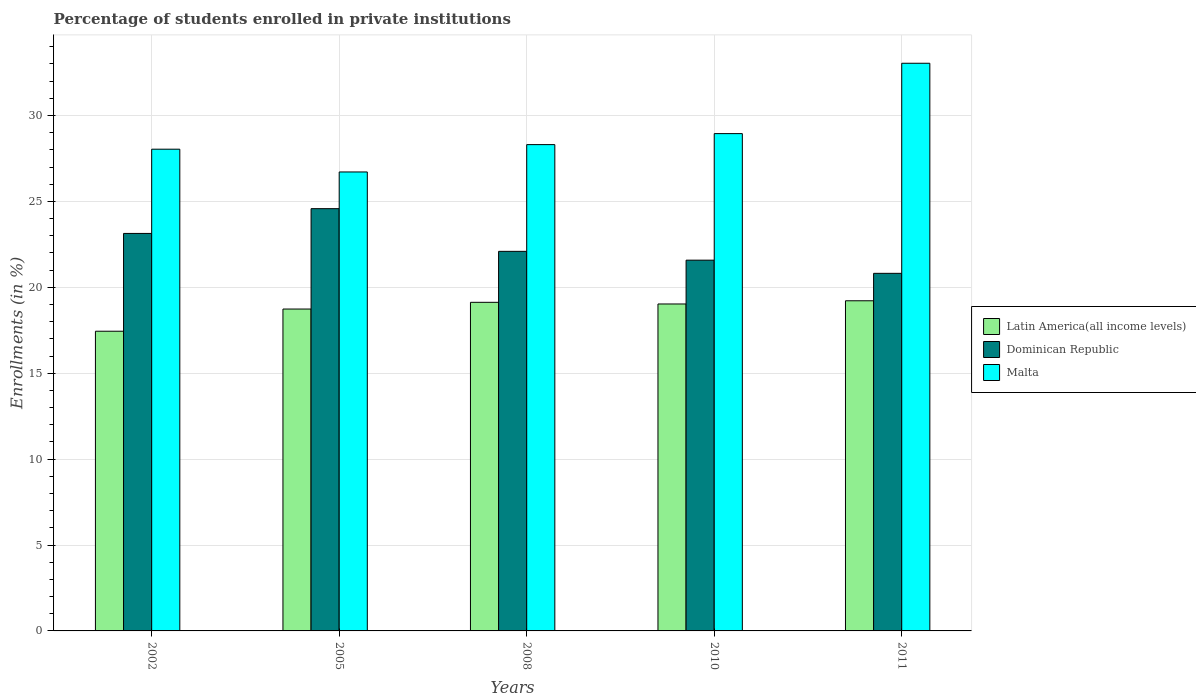How many groups of bars are there?
Provide a short and direct response. 5. Are the number of bars per tick equal to the number of legend labels?
Offer a very short reply. Yes. How many bars are there on the 4th tick from the left?
Provide a succinct answer. 3. What is the percentage of trained teachers in Dominican Republic in 2005?
Provide a succinct answer. 24.58. Across all years, what is the maximum percentage of trained teachers in Latin America(all income levels)?
Ensure brevity in your answer.  19.22. Across all years, what is the minimum percentage of trained teachers in Malta?
Provide a succinct answer. 26.71. In which year was the percentage of trained teachers in Malta maximum?
Provide a short and direct response. 2011. In which year was the percentage of trained teachers in Dominican Republic minimum?
Keep it short and to the point. 2011. What is the total percentage of trained teachers in Dominican Republic in the graph?
Give a very brief answer. 112.2. What is the difference between the percentage of trained teachers in Latin America(all income levels) in 2005 and that in 2008?
Ensure brevity in your answer.  -0.39. What is the difference between the percentage of trained teachers in Malta in 2008 and the percentage of trained teachers in Dominican Republic in 2010?
Provide a succinct answer. 6.72. What is the average percentage of trained teachers in Dominican Republic per year?
Make the answer very short. 22.44. In the year 2002, what is the difference between the percentage of trained teachers in Malta and percentage of trained teachers in Latin America(all income levels)?
Keep it short and to the point. 10.59. What is the ratio of the percentage of trained teachers in Malta in 2002 to that in 2011?
Ensure brevity in your answer.  0.85. Is the percentage of trained teachers in Latin America(all income levels) in 2005 less than that in 2011?
Your response must be concise. Yes. Is the difference between the percentage of trained teachers in Malta in 2002 and 2011 greater than the difference between the percentage of trained teachers in Latin America(all income levels) in 2002 and 2011?
Make the answer very short. No. What is the difference between the highest and the second highest percentage of trained teachers in Latin America(all income levels)?
Your answer should be very brief. 0.09. What is the difference between the highest and the lowest percentage of trained teachers in Latin America(all income levels)?
Offer a terse response. 1.77. In how many years, is the percentage of trained teachers in Latin America(all income levels) greater than the average percentage of trained teachers in Latin America(all income levels) taken over all years?
Ensure brevity in your answer.  4. What does the 2nd bar from the left in 2011 represents?
Make the answer very short. Dominican Republic. What does the 3rd bar from the right in 2010 represents?
Your answer should be compact. Latin America(all income levels). Is it the case that in every year, the sum of the percentage of trained teachers in Malta and percentage of trained teachers in Latin America(all income levels) is greater than the percentage of trained teachers in Dominican Republic?
Your response must be concise. Yes. Does the graph contain grids?
Your response must be concise. Yes. Where does the legend appear in the graph?
Give a very brief answer. Center right. How many legend labels are there?
Give a very brief answer. 3. What is the title of the graph?
Keep it short and to the point. Percentage of students enrolled in private institutions. Does "Mauritania" appear as one of the legend labels in the graph?
Ensure brevity in your answer.  No. What is the label or title of the Y-axis?
Provide a short and direct response. Enrollments (in %). What is the Enrollments (in %) in Latin America(all income levels) in 2002?
Your answer should be compact. 17.44. What is the Enrollments (in %) of Dominican Republic in 2002?
Provide a short and direct response. 23.14. What is the Enrollments (in %) of Malta in 2002?
Keep it short and to the point. 28.04. What is the Enrollments (in %) of Latin America(all income levels) in 2005?
Provide a succinct answer. 18.73. What is the Enrollments (in %) of Dominican Republic in 2005?
Provide a short and direct response. 24.58. What is the Enrollments (in %) of Malta in 2005?
Keep it short and to the point. 26.71. What is the Enrollments (in %) in Latin America(all income levels) in 2008?
Your response must be concise. 19.13. What is the Enrollments (in %) of Dominican Republic in 2008?
Ensure brevity in your answer.  22.09. What is the Enrollments (in %) in Malta in 2008?
Offer a very short reply. 28.31. What is the Enrollments (in %) of Latin America(all income levels) in 2010?
Ensure brevity in your answer.  19.03. What is the Enrollments (in %) in Dominican Republic in 2010?
Give a very brief answer. 21.58. What is the Enrollments (in %) of Malta in 2010?
Your answer should be very brief. 28.95. What is the Enrollments (in %) in Latin America(all income levels) in 2011?
Your response must be concise. 19.22. What is the Enrollments (in %) in Dominican Republic in 2011?
Give a very brief answer. 20.81. What is the Enrollments (in %) in Malta in 2011?
Offer a terse response. 33.04. Across all years, what is the maximum Enrollments (in %) of Latin America(all income levels)?
Keep it short and to the point. 19.22. Across all years, what is the maximum Enrollments (in %) in Dominican Republic?
Provide a succinct answer. 24.58. Across all years, what is the maximum Enrollments (in %) of Malta?
Your answer should be compact. 33.04. Across all years, what is the minimum Enrollments (in %) of Latin America(all income levels)?
Your response must be concise. 17.44. Across all years, what is the minimum Enrollments (in %) in Dominican Republic?
Your answer should be very brief. 20.81. Across all years, what is the minimum Enrollments (in %) in Malta?
Keep it short and to the point. 26.71. What is the total Enrollments (in %) in Latin America(all income levels) in the graph?
Your answer should be very brief. 93.55. What is the total Enrollments (in %) in Dominican Republic in the graph?
Offer a very short reply. 112.2. What is the total Enrollments (in %) of Malta in the graph?
Offer a terse response. 145.04. What is the difference between the Enrollments (in %) in Latin America(all income levels) in 2002 and that in 2005?
Ensure brevity in your answer.  -1.29. What is the difference between the Enrollments (in %) in Dominican Republic in 2002 and that in 2005?
Give a very brief answer. -1.44. What is the difference between the Enrollments (in %) in Malta in 2002 and that in 2005?
Give a very brief answer. 1.32. What is the difference between the Enrollments (in %) of Latin America(all income levels) in 2002 and that in 2008?
Offer a very short reply. -1.68. What is the difference between the Enrollments (in %) of Dominican Republic in 2002 and that in 2008?
Make the answer very short. 1.04. What is the difference between the Enrollments (in %) in Malta in 2002 and that in 2008?
Give a very brief answer. -0.27. What is the difference between the Enrollments (in %) in Latin America(all income levels) in 2002 and that in 2010?
Offer a very short reply. -1.59. What is the difference between the Enrollments (in %) in Dominican Republic in 2002 and that in 2010?
Make the answer very short. 1.56. What is the difference between the Enrollments (in %) of Malta in 2002 and that in 2010?
Make the answer very short. -0.91. What is the difference between the Enrollments (in %) in Latin America(all income levels) in 2002 and that in 2011?
Keep it short and to the point. -1.77. What is the difference between the Enrollments (in %) of Dominican Republic in 2002 and that in 2011?
Ensure brevity in your answer.  2.32. What is the difference between the Enrollments (in %) in Malta in 2002 and that in 2011?
Provide a succinct answer. -5. What is the difference between the Enrollments (in %) in Latin America(all income levels) in 2005 and that in 2008?
Provide a succinct answer. -0.39. What is the difference between the Enrollments (in %) in Dominican Republic in 2005 and that in 2008?
Provide a succinct answer. 2.48. What is the difference between the Enrollments (in %) in Malta in 2005 and that in 2008?
Your answer should be very brief. -1.59. What is the difference between the Enrollments (in %) in Latin America(all income levels) in 2005 and that in 2010?
Your answer should be very brief. -0.3. What is the difference between the Enrollments (in %) of Dominican Republic in 2005 and that in 2010?
Offer a terse response. 3. What is the difference between the Enrollments (in %) in Malta in 2005 and that in 2010?
Ensure brevity in your answer.  -2.23. What is the difference between the Enrollments (in %) in Latin America(all income levels) in 2005 and that in 2011?
Offer a terse response. -0.48. What is the difference between the Enrollments (in %) of Dominican Republic in 2005 and that in 2011?
Give a very brief answer. 3.76. What is the difference between the Enrollments (in %) in Malta in 2005 and that in 2011?
Your answer should be very brief. -6.33. What is the difference between the Enrollments (in %) in Latin America(all income levels) in 2008 and that in 2010?
Your response must be concise. 0.1. What is the difference between the Enrollments (in %) of Dominican Republic in 2008 and that in 2010?
Ensure brevity in your answer.  0.51. What is the difference between the Enrollments (in %) of Malta in 2008 and that in 2010?
Ensure brevity in your answer.  -0.64. What is the difference between the Enrollments (in %) in Latin America(all income levels) in 2008 and that in 2011?
Provide a succinct answer. -0.09. What is the difference between the Enrollments (in %) of Dominican Republic in 2008 and that in 2011?
Offer a terse response. 1.28. What is the difference between the Enrollments (in %) in Malta in 2008 and that in 2011?
Keep it short and to the point. -4.74. What is the difference between the Enrollments (in %) in Latin America(all income levels) in 2010 and that in 2011?
Ensure brevity in your answer.  -0.19. What is the difference between the Enrollments (in %) of Dominican Republic in 2010 and that in 2011?
Offer a very short reply. 0.77. What is the difference between the Enrollments (in %) in Malta in 2010 and that in 2011?
Make the answer very short. -4.1. What is the difference between the Enrollments (in %) of Latin America(all income levels) in 2002 and the Enrollments (in %) of Dominican Republic in 2005?
Ensure brevity in your answer.  -7.13. What is the difference between the Enrollments (in %) in Latin America(all income levels) in 2002 and the Enrollments (in %) in Malta in 2005?
Ensure brevity in your answer.  -9.27. What is the difference between the Enrollments (in %) in Dominican Republic in 2002 and the Enrollments (in %) in Malta in 2005?
Provide a succinct answer. -3.58. What is the difference between the Enrollments (in %) of Latin America(all income levels) in 2002 and the Enrollments (in %) of Dominican Republic in 2008?
Offer a terse response. -4.65. What is the difference between the Enrollments (in %) of Latin America(all income levels) in 2002 and the Enrollments (in %) of Malta in 2008?
Keep it short and to the point. -10.86. What is the difference between the Enrollments (in %) of Dominican Republic in 2002 and the Enrollments (in %) of Malta in 2008?
Offer a terse response. -5.17. What is the difference between the Enrollments (in %) of Latin America(all income levels) in 2002 and the Enrollments (in %) of Dominican Republic in 2010?
Your response must be concise. -4.14. What is the difference between the Enrollments (in %) of Latin America(all income levels) in 2002 and the Enrollments (in %) of Malta in 2010?
Provide a short and direct response. -11.5. What is the difference between the Enrollments (in %) of Dominican Republic in 2002 and the Enrollments (in %) of Malta in 2010?
Your answer should be very brief. -5.81. What is the difference between the Enrollments (in %) in Latin America(all income levels) in 2002 and the Enrollments (in %) in Dominican Republic in 2011?
Your response must be concise. -3.37. What is the difference between the Enrollments (in %) of Latin America(all income levels) in 2002 and the Enrollments (in %) of Malta in 2011?
Your answer should be very brief. -15.6. What is the difference between the Enrollments (in %) of Dominican Republic in 2002 and the Enrollments (in %) of Malta in 2011?
Your answer should be compact. -9.91. What is the difference between the Enrollments (in %) in Latin America(all income levels) in 2005 and the Enrollments (in %) in Dominican Republic in 2008?
Your answer should be very brief. -3.36. What is the difference between the Enrollments (in %) of Latin America(all income levels) in 2005 and the Enrollments (in %) of Malta in 2008?
Provide a short and direct response. -9.57. What is the difference between the Enrollments (in %) of Dominican Republic in 2005 and the Enrollments (in %) of Malta in 2008?
Offer a very short reply. -3.73. What is the difference between the Enrollments (in %) of Latin America(all income levels) in 2005 and the Enrollments (in %) of Dominican Republic in 2010?
Offer a very short reply. -2.85. What is the difference between the Enrollments (in %) in Latin America(all income levels) in 2005 and the Enrollments (in %) in Malta in 2010?
Ensure brevity in your answer.  -10.21. What is the difference between the Enrollments (in %) of Dominican Republic in 2005 and the Enrollments (in %) of Malta in 2010?
Keep it short and to the point. -4.37. What is the difference between the Enrollments (in %) in Latin America(all income levels) in 2005 and the Enrollments (in %) in Dominican Republic in 2011?
Your response must be concise. -2.08. What is the difference between the Enrollments (in %) of Latin America(all income levels) in 2005 and the Enrollments (in %) of Malta in 2011?
Offer a very short reply. -14.31. What is the difference between the Enrollments (in %) in Dominican Republic in 2005 and the Enrollments (in %) in Malta in 2011?
Your answer should be compact. -8.46. What is the difference between the Enrollments (in %) of Latin America(all income levels) in 2008 and the Enrollments (in %) of Dominican Republic in 2010?
Ensure brevity in your answer.  -2.45. What is the difference between the Enrollments (in %) of Latin America(all income levels) in 2008 and the Enrollments (in %) of Malta in 2010?
Keep it short and to the point. -9.82. What is the difference between the Enrollments (in %) of Dominican Republic in 2008 and the Enrollments (in %) of Malta in 2010?
Your answer should be very brief. -6.85. What is the difference between the Enrollments (in %) in Latin America(all income levels) in 2008 and the Enrollments (in %) in Dominican Republic in 2011?
Give a very brief answer. -1.69. What is the difference between the Enrollments (in %) in Latin America(all income levels) in 2008 and the Enrollments (in %) in Malta in 2011?
Your answer should be compact. -13.91. What is the difference between the Enrollments (in %) of Dominican Republic in 2008 and the Enrollments (in %) of Malta in 2011?
Your answer should be very brief. -10.95. What is the difference between the Enrollments (in %) of Latin America(all income levels) in 2010 and the Enrollments (in %) of Dominican Republic in 2011?
Provide a short and direct response. -1.78. What is the difference between the Enrollments (in %) in Latin America(all income levels) in 2010 and the Enrollments (in %) in Malta in 2011?
Your answer should be very brief. -14.01. What is the difference between the Enrollments (in %) in Dominican Republic in 2010 and the Enrollments (in %) in Malta in 2011?
Make the answer very short. -11.46. What is the average Enrollments (in %) of Latin America(all income levels) per year?
Offer a very short reply. 18.71. What is the average Enrollments (in %) in Dominican Republic per year?
Keep it short and to the point. 22.44. What is the average Enrollments (in %) in Malta per year?
Your response must be concise. 29.01. In the year 2002, what is the difference between the Enrollments (in %) in Latin America(all income levels) and Enrollments (in %) in Dominican Republic?
Provide a succinct answer. -5.69. In the year 2002, what is the difference between the Enrollments (in %) in Latin America(all income levels) and Enrollments (in %) in Malta?
Make the answer very short. -10.59. In the year 2002, what is the difference between the Enrollments (in %) in Dominican Republic and Enrollments (in %) in Malta?
Provide a short and direct response. -4.9. In the year 2005, what is the difference between the Enrollments (in %) of Latin America(all income levels) and Enrollments (in %) of Dominican Republic?
Give a very brief answer. -5.84. In the year 2005, what is the difference between the Enrollments (in %) in Latin America(all income levels) and Enrollments (in %) in Malta?
Your answer should be compact. -7.98. In the year 2005, what is the difference between the Enrollments (in %) in Dominican Republic and Enrollments (in %) in Malta?
Offer a very short reply. -2.14. In the year 2008, what is the difference between the Enrollments (in %) of Latin America(all income levels) and Enrollments (in %) of Dominican Republic?
Keep it short and to the point. -2.97. In the year 2008, what is the difference between the Enrollments (in %) in Latin America(all income levels) and Enrollments (in %) in Malta?
Your response must be concise. -9.18. In the year 2008, what is the difference between the Enrollments (in %) of Dominican Republic and Enrollments (in %) of Malta?
Keep it short and to the point. -6.21. In the year 2010, what is the difference between the Enrollments (in %) in Latin America(all income levels) and Enrollments (in %) in Dominican Republic?
Provide a succinct answer. -2.55. In the year 2010, what is the difference between the Enrollments (in %) in Latin America(all income levels) and Enrollments (in %) in Malta?
Your answer should be compact. -9.92. In the year 2010, what is the difference between the Enrollments (in %) in Dominican Republic and Enrollments (in %) in Malta?
Your answer should be very brief. -7.37. In the year 2011, what is the difference between the Enrollments (in %) of Latin America(all income levels) and Enrollments (in %) of Dominican Republic?
Offer a very short reply. -1.6. In the year 2011, what is the difference between the Enrollments (in %) of Latin America(all income levels) and Enrollments (in %) of Malta?
Your response must be concise. -13.82. In the year 2011, what is the difference between the Enrollments (in %) of Dominican Republic and Enrollments (in %) of Malta?
Your answer should be very brief. -12.23. What is the ratio of the Enrollments (in %) in Latin America(all income levels) in 2002 to that in 2005?
Give a very brief answer. 0.93. What is the ratio of the Enrollments (in %) in Dominican Republic in 2002 to that in 2005?
Make the answer very short. 0.94. What is the ratio of the Enrollments (in %) of Malta in 2002 to that in 2005?
Ensure brevity in your answer.  1.05. What is the ratio of the Enrollments (in %) of Latin America(all income levels) in 2002 to that in 2008?
Keep it short and to the point. 0.91. What is the ratio of the Enrollments (in %) in Dominican Republic in 2002 to that in 2008?
Offer a very short reply. 1.05. What is the ratio of the Enrollments (in %) of Malta in 2002 to that in 2008?
Your answer should be compact. 0.99. What is the ratio of the Enrollments (in %) in Dominican Republic in 2002 to that in 2010?
Provide a short and direct response. 1.07. What is the ratio of the Enrollments (in %) of Malta in 2002 to that in 2010?
Offer a terse response. 0.97. What is the ratio of the Enrollments (in %) of Latin America(all income levels) in 2002 to that in 2011?
Your answer should be compact. 0.91. What is the ratio of the Enrollments (in %) of Dominican Republic in 2002 to that in 2011?
Offer a terse response. 1.11. What is the ratio of the Enrollments (in %) in Malta in 2002 to that in 2011?
Offer a very short reply. 0.85. What is the ratio of the Enrollments (in %) in Latin America(all income levels) in 2005 to that in 2008?
Offer a very short reply. 0.98. What is the ratio of the Enrollments (in %) in Dominican Republic in 2005 to that in 2008?
Offer a terse response. 1.11. What is the ratio of the Enrollments (in %) of Malta in 2005 to that in 2008?
Your response must be concise. 0.94. What is the ratio of the Enrollments (in %) in Latin America(all income levels) in 2005 to that in 2010?
Provide a succinct answer. 0.98. What is the ratio of the Enrollments (in %) in Dominican Republic in 2005 to that in 2010?
Provide a succinct answer. 1.14. What is the ratio of the Enrollments (in %) of Malta in 2005 to that in 2010?
Give a very brief answer. 0.92. What is the ratio of the Enrollments (in %) of Dominican Republic in 2005 to that in 2011?
Provide a short and direct response. 1.18. What is the ratio of the Enrollments (in %) of Malta in 2005 to that in 2011?
Provide a succinct answer. 0.81. What is the ratio of the Enrollments (in %) in Dominican Republic in 2008 to that in 2010?
Provide a short and direct response. 1.02. What is the ratio of the Enrollments (in %) of Malta in 2008 to that in 2010?
Your response must be concise. 0.98. What is the ratio of the Enrollments (in %) in Latin America(all income levels) in 2008 to that in 2011?
Your response must be concise. 1. What is the ratio of the Enrollments (in %) of Dominican Republic in 2008 to that in 2011?
Ensure brevity in your answer.  1.06. What is the ratio of the Enrollments (in %) of Malta in 2008 to that in 2011?
Provide a short and direct response. 0.86. What is the ratio of the Enrollments (in %) in Latin America(all income levels) in 2010 to that in 2011?
Your response must be concise. 0.99. What is the ratio of the Enrollments (in %) in Dominican Republic in 2010 to that in 2011?
Ensure brevity in your answer.  1.04. What is the ratio of the Enrollments (in %) in Malta in 2010 to that in 2011?
Provide a short and direct response. 0.88. What is the difference between the highest and the second highest Enrollments (in %) in Latin America(all income levels)?
Provide a succinct answer. 0.09. What is the difference between the highest and the second highest Enrollments (in %) in Dominican Republic?
Keep it short and to the point. 1.44. What is the difference between the highest and the second highest Enrollments (in %) in Malta?
Provide a short and direct response. 4.1. What is the difference between the highest and the lowest Enrollments (in %) in Latin America(all income levels)?
Give a very brief answer. 1.77. What is the difference between the highest and the lowest Enrollments (in %) in Dominican Republic?
Ensure brevity in your answer.  3.76. What is the difference between the highest and the lowest Enrollments (in %) of Malta?
Provide a succinct answer. 6.33. 